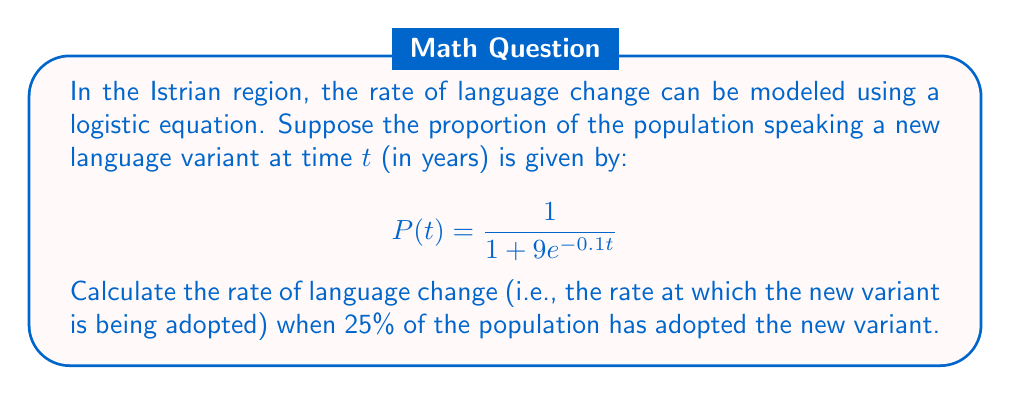Teach me how to tackle this problem. To solve this problem, we need to follow these steps:

1) The rate of language change is given by the derivative of $P(t)$ with respect to $t$. Let's call this $\frac{dP}{dt}$.

2) To find $\frac{dP}{dt}$, we use the chain rule:

   $$\frac{dP}{dt} = \frac{9e^{-0.1t}}{(1 + 9e^{-0.1t})^2} \cdot 0.1$$

3) We need to find when 25% of the population has adopted the new variant. This means $P(t) = 0.25$:

   $$0.25 = \frac{1}{1 + 9e^{-0.1t}}$$

4) Solving this equation:
   
   $$1 + 9e^{-0.1t} = 4$$
   $$9e^{-0.1t} = 3$$
   $$e^{-0.1t} = \frac{1}{3}$$
   $$-0.1t = \ln(\frac{1}{3})$$
   $$t = -10\ln(\frac{1}{3}) \approx 10.99$$

5) Now we can substitute this value of $t$ back into our expression for $\frac{dP}{dt}$:

   $$\frac{dP}{dt} = \frac{9e^{-0.1(10.99)}}{(1 + 9e^{-0.1(10.99)})^2} \cdot 0.1$$

6) Simplifying:

   $$\frac{dP}{dt} = \frac{9(\frac{1}{3})}{(1 + 9(\frac{1}{3}))^2} \cdot 0.1 = \frac{3}{16} \cdot 0.1 = 0.01875$$

Therefore, when 25% of the population has adopted the new variant, the rate of language change is 0.01875 or 1.875% per year.
Answer: The rate of language change when 25% of the population has adopted the new variant is 0.01875 or 1.875% per year. 